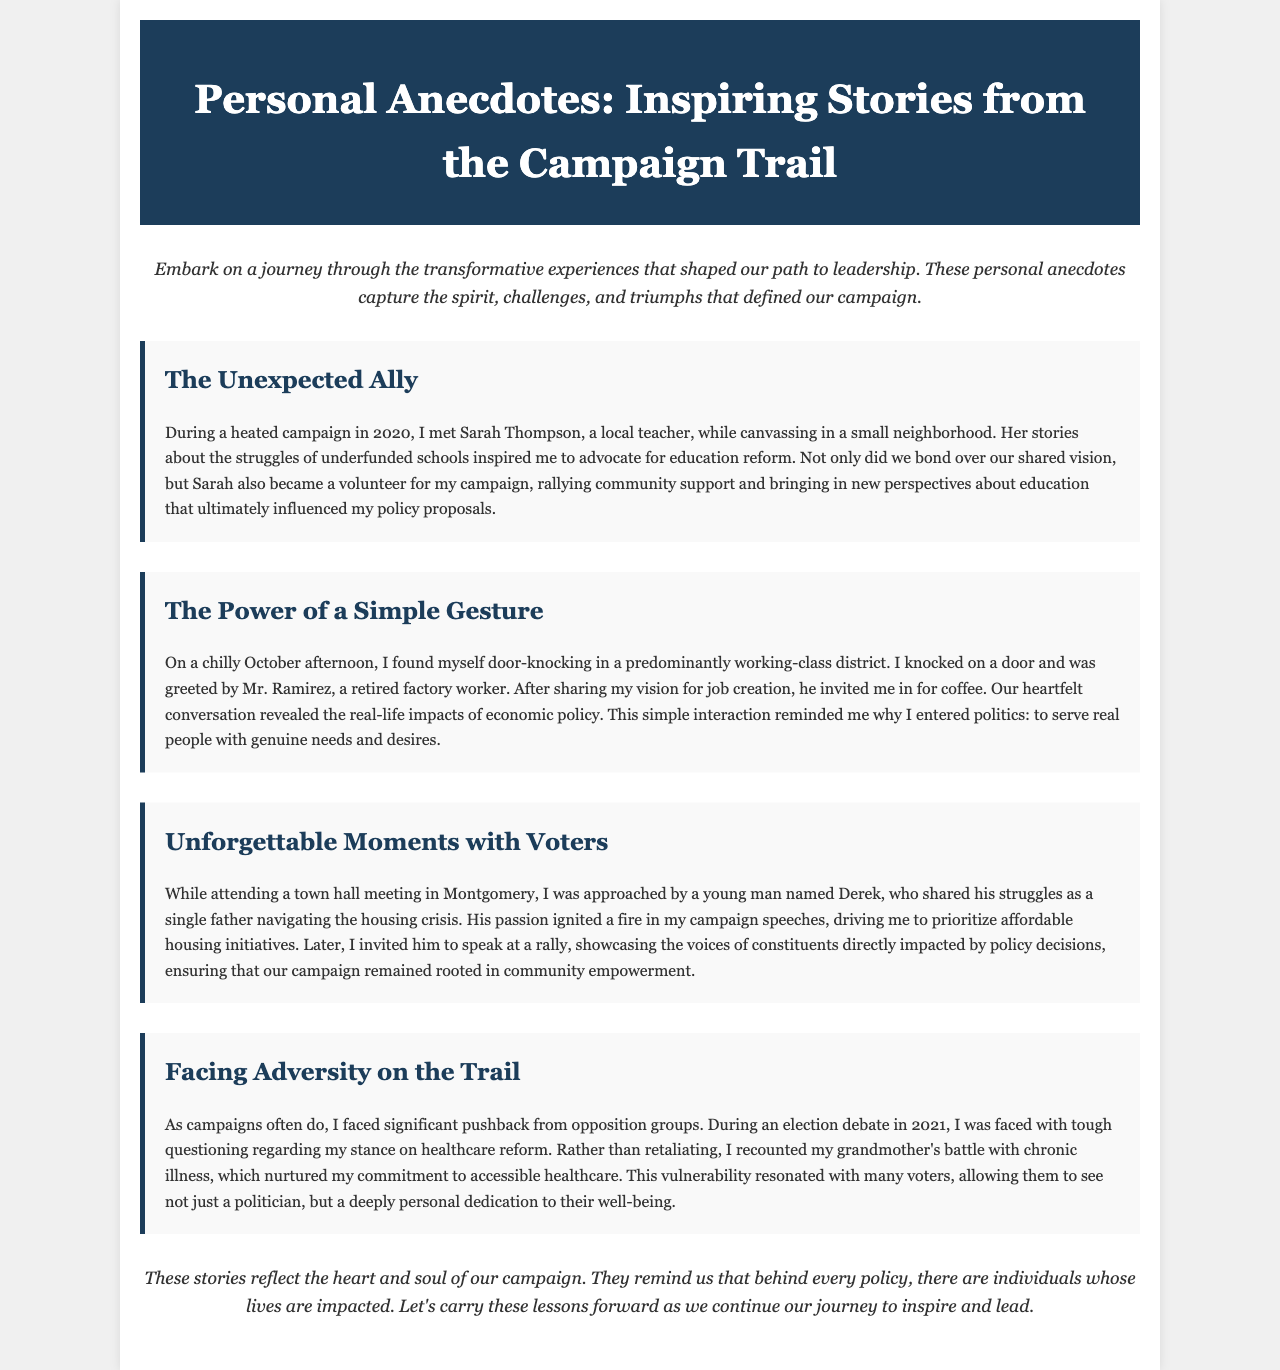what is the title of the brochure? The title of the brochure is prominently displayed in the header section of the document.
Answer: Personal Anecdotes: Inspiring Stories from the Campaign Trail who is featured in "The Unexpected Ally" story? The story focuses on a local teacher, emphasizing her contribution to the campaign.
Answer: Sarah Thompson which struggle did Mr. Ramirez discuss during the conversation? The story describes Mr. Ramirez's insights regarding economic policy and its real-life impacts.
Answer: Economic policy what year did the campaign mentioned in "The Unexpected Ally" take place? The story indicates that the campaign events unfolded during a specific year.
Answer: 2020 what type of gesture impacted the author's perspective on politics in "The Power of a Simple Gesture"? The author reflects on the significance of a welcoming invitation during a campaign interaction.
Answer: Coffee in which town did the meeting with Derek occur? This detail highlights the location where the author engaged with a key voter.
Answer: Montgomery what was the key topic during the 2021 election debate mentioned? This aspect of the document outlines a specific critical issue faced by the author during the debate.
Answer: Healthcare reform how does the author feel about meeting constituents like Derek? The author's emotions highlight the importance of connecting with voters on a personal level.
Answer: Empowered what is the overall theme of the brochure? The document summarizes its core message in the introduction and conclusion sections.
Answer: Community empowerment 